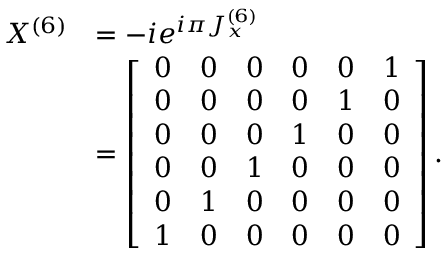<formula> <loc_0><loc_0><loc_500><loc_500>\begin{array} { r l } { X ^ { ( 6 ) } } & { = - i e ^ { i \pi J _ { x } ^ { ( 6 ) } } } \\ & { = \left [ \begin{array} { l l l l l l } { 0 } & { 0 } & { 0 } & { 0 } & { 0 } & { 1 } \\ { 0 } & { 0 } & { 0 } & { 0 } & { 1 } & { 0 } \\ { 0 } & { 0 } & { 0 } & { 1 } & { 0 } & { 0 } \\ { 0 } & { 0 } & { 1 } & { 0 } & { 0 } & { 0 } \\ { 0 } & { 1 } & { 0 } & { 0 } & { 0 } & { 0 } \\ { 1 } & { 0 } & { 0 } & { 0 } & { 0 } & { 0 } \end{array} \right ] . } \end{array}</formula> 